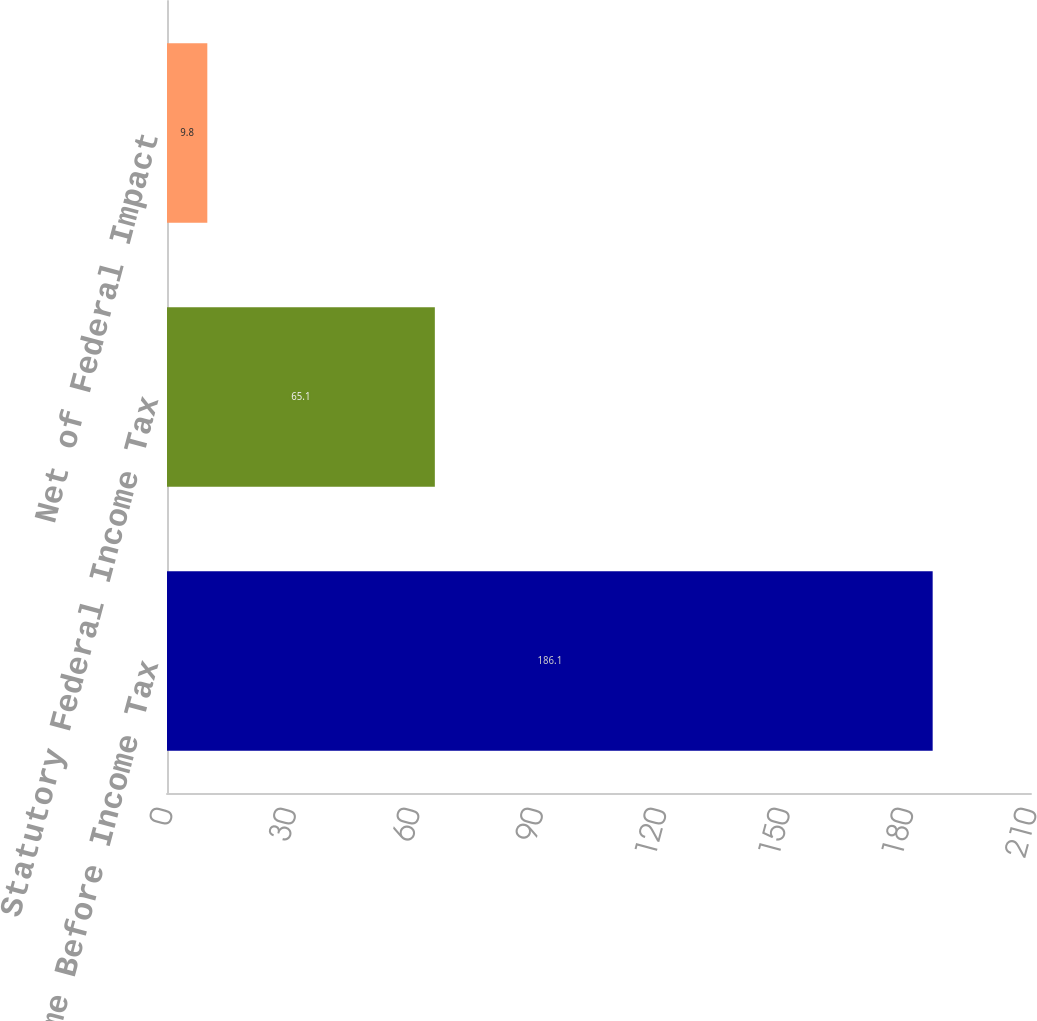<chart> <loc_0><loc_0><loc_500><loc_500><bar_chart><fcel>Income Before Income Tax<fcel>Statutory Federal Income Tax<fcel>Net of Federal Impact<nl><fcel>186.1<fcel>65.1<fcel>9.8<nl></chart> 